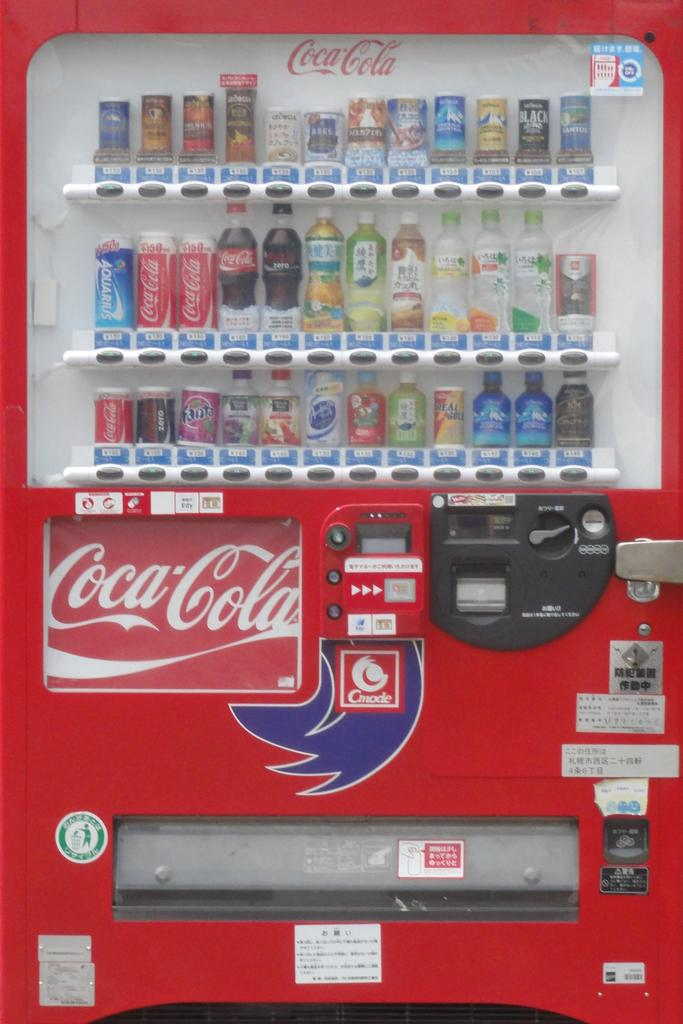<image>
Summarize the visual content of the image. A soda machine that is labeled with coca cola on it and on the products. 